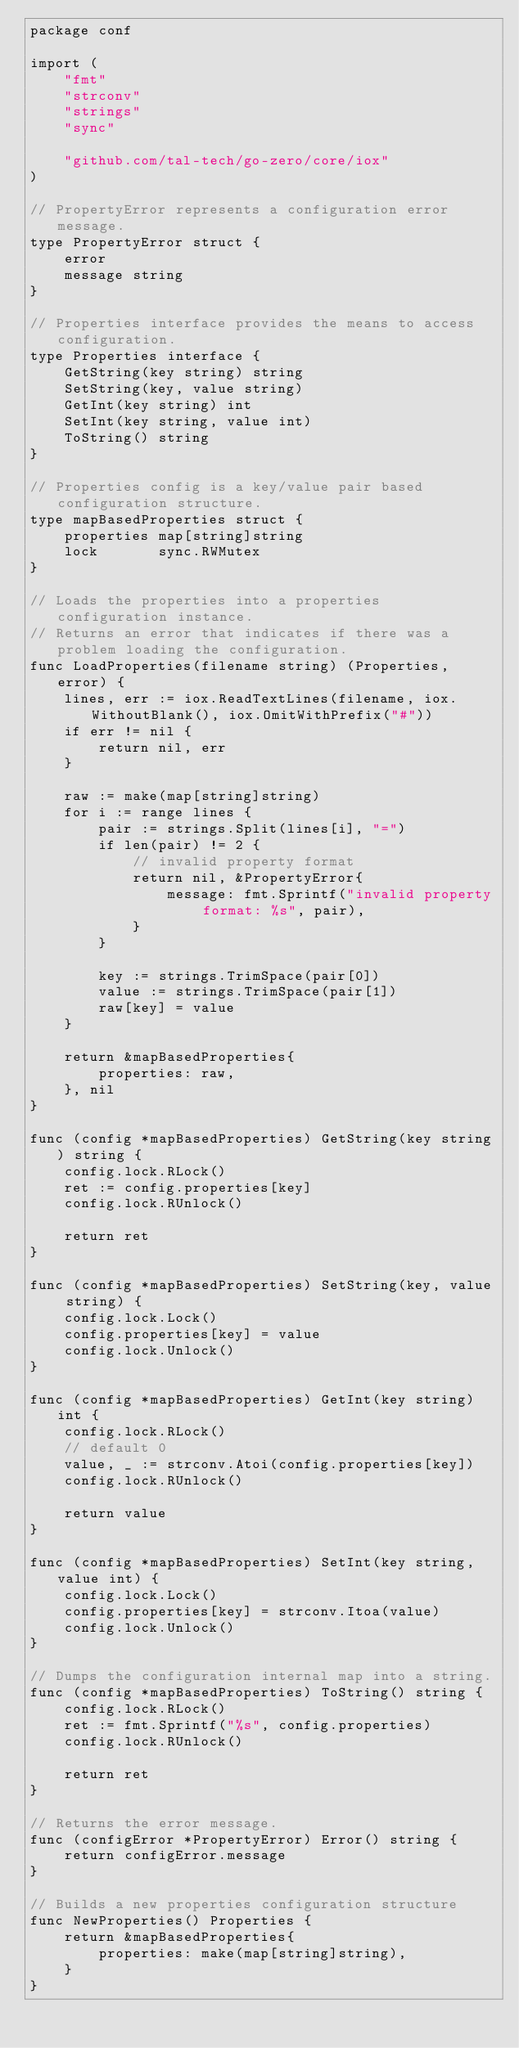<code> <loc_0><loc_0><loc_500><loc_500><_Go_>package conf

import (
	"fmt"
	"strconv"
	"strings"
	"sync"

	"github.com/tal-tech/go-zero/core/iox"
)

// PropertyError represents a configuration error message.
type PropertyError struct {
	error
	message string
}

// Properties interface provides the means to access configuration.
type Properties interface {
	GetString(key string) string
	SetString(key, value string)
	GetInt(key string) int
	SetInt(key string, value int)
	ToString() string
}

// Properties config is a key/value pair based configuration structure.
type mapBasedProperties struct {
	properties map[string]string
	lock       sync.RWMutex
}

// Loads the properties into a properties configuration instance.
// Returns an error that indicates if there was a problem loading the configuration.
func LoadProperties(filename string) (Properties, error) {
	lines, err := iox.ReadTextLines(filename, iox.WithoutBlank(), iox.OmitWithPrefix("#"))
	if err != nil {
		return nil, err
	}

	raw := make(map[string]string)
	for i := range lines {
		pair := strings.Split(lines[i], "=")
		if len(pair) != 2 {
			// invalid property format
			return nil, &PropertyError{
				message: fmt.Sprintf("invalid property format: %s", pair),
			}
		}

		key := strings.TrimSpace(pair[0])
		value := strings.TrimSpace(pair[1])
		raw[key] = value
	}

	return &mapBasedProperties{
		properties: raw,
	}, nil
}

func (config *mapBasedProperties) GetString(key string) string {
	config.lock.RLock()
	ret := config.properties[key]
	config.lock.RUnlock()

	return ret
}

func (config *mapBasedProperties) SetString(key, value string) {
	config.lock.Lock()
	config.properties[key] = value
	config.lock.Unlock()
}

func (config *mapBasedProperties) GetInt(key string) int {
	config.lock.RLock()
	// default 0
	value, _ := strconv.Atoi(config.properties[key])
	config.lock.RUnlock()

	return value
}

func (config *mapBasedProperties) SetInt(key string, value int) {
	config.lock.Lock()
	config.properties[key] = strconv.Itoa(value)
	config.lock.Unlock()
}

// Dumps the configuration internal map into a string.
func (config *mapBasedProperties) ToString() string {
	config.lock.RLock()
	ret := fmt.Sprintf("%s", config.properties)
	config.lock.RUnlock()

	return ret
}

// Returns the error message.
func (configError *PropertyError) Error() string {
	return configError.message
}

// Builds a new properties configuration structure
func NewProperties() Properties {
	return &mapBasedProperties{
		properties: make(map[string]string),
	}
}
</code> 